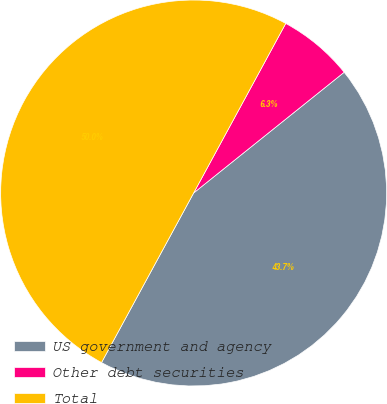Convert chart. <chart><loc_0><loc_0><loc_500><loc_500><pie_chart><fcel>US government and agency<fcel>Other debt securities<fcel>Total<nl><fcel>43.68%<fcel>6.32%<fcel>50.0%<nl></chart> 